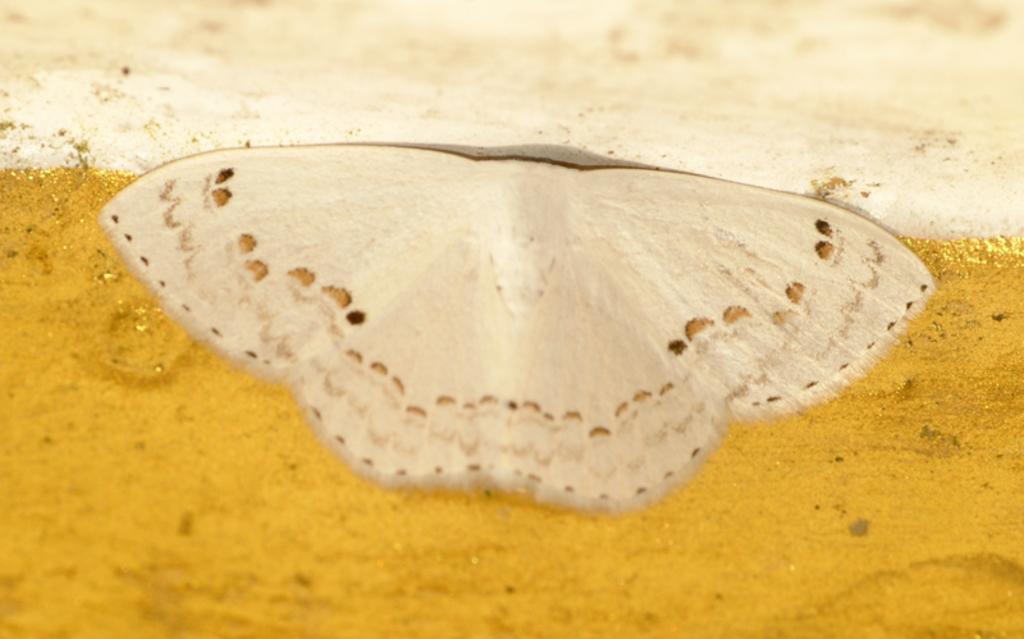Please provide a concise description of this image. In the middle of the image there is a butterfly on the surface. The surface is golden yellow in color. 